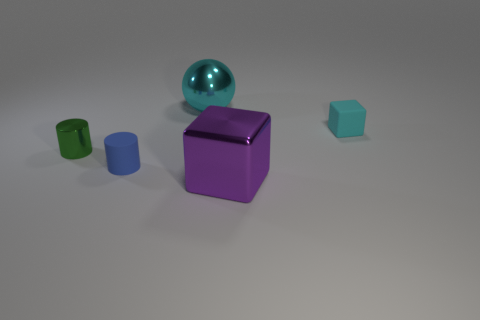Add 2 big cyan shiny objects. How many objects exist? 7 Subtract all cylinders. How many objects are left? 3 Subtract 0 blue blocks. How many objects are left? 5 Subtract all big blocks. Subtract all small cyan rubber balls. How many objects are left? 4 Add 5 big cyan shiny objects. How many big cyan shiny objects are left? 6 Add 3 small cyan rubber objects. How many small cyan rubber objects exist? 4 